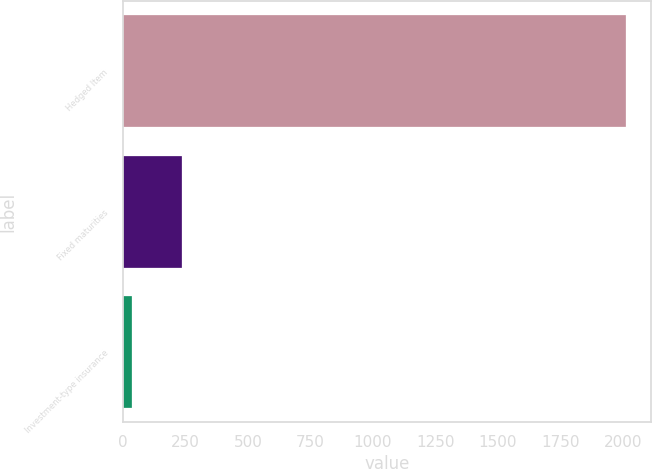Convert chart. <chart><loc_0><loc_0><loc_500><loc_500><bar_chart><fcel>Hedged Item<fcel>Fixed maturities<fcel>Investment-type insurance<nl><fcel>2012<fcel>234.59<fcel>37.1<nl></chart> 